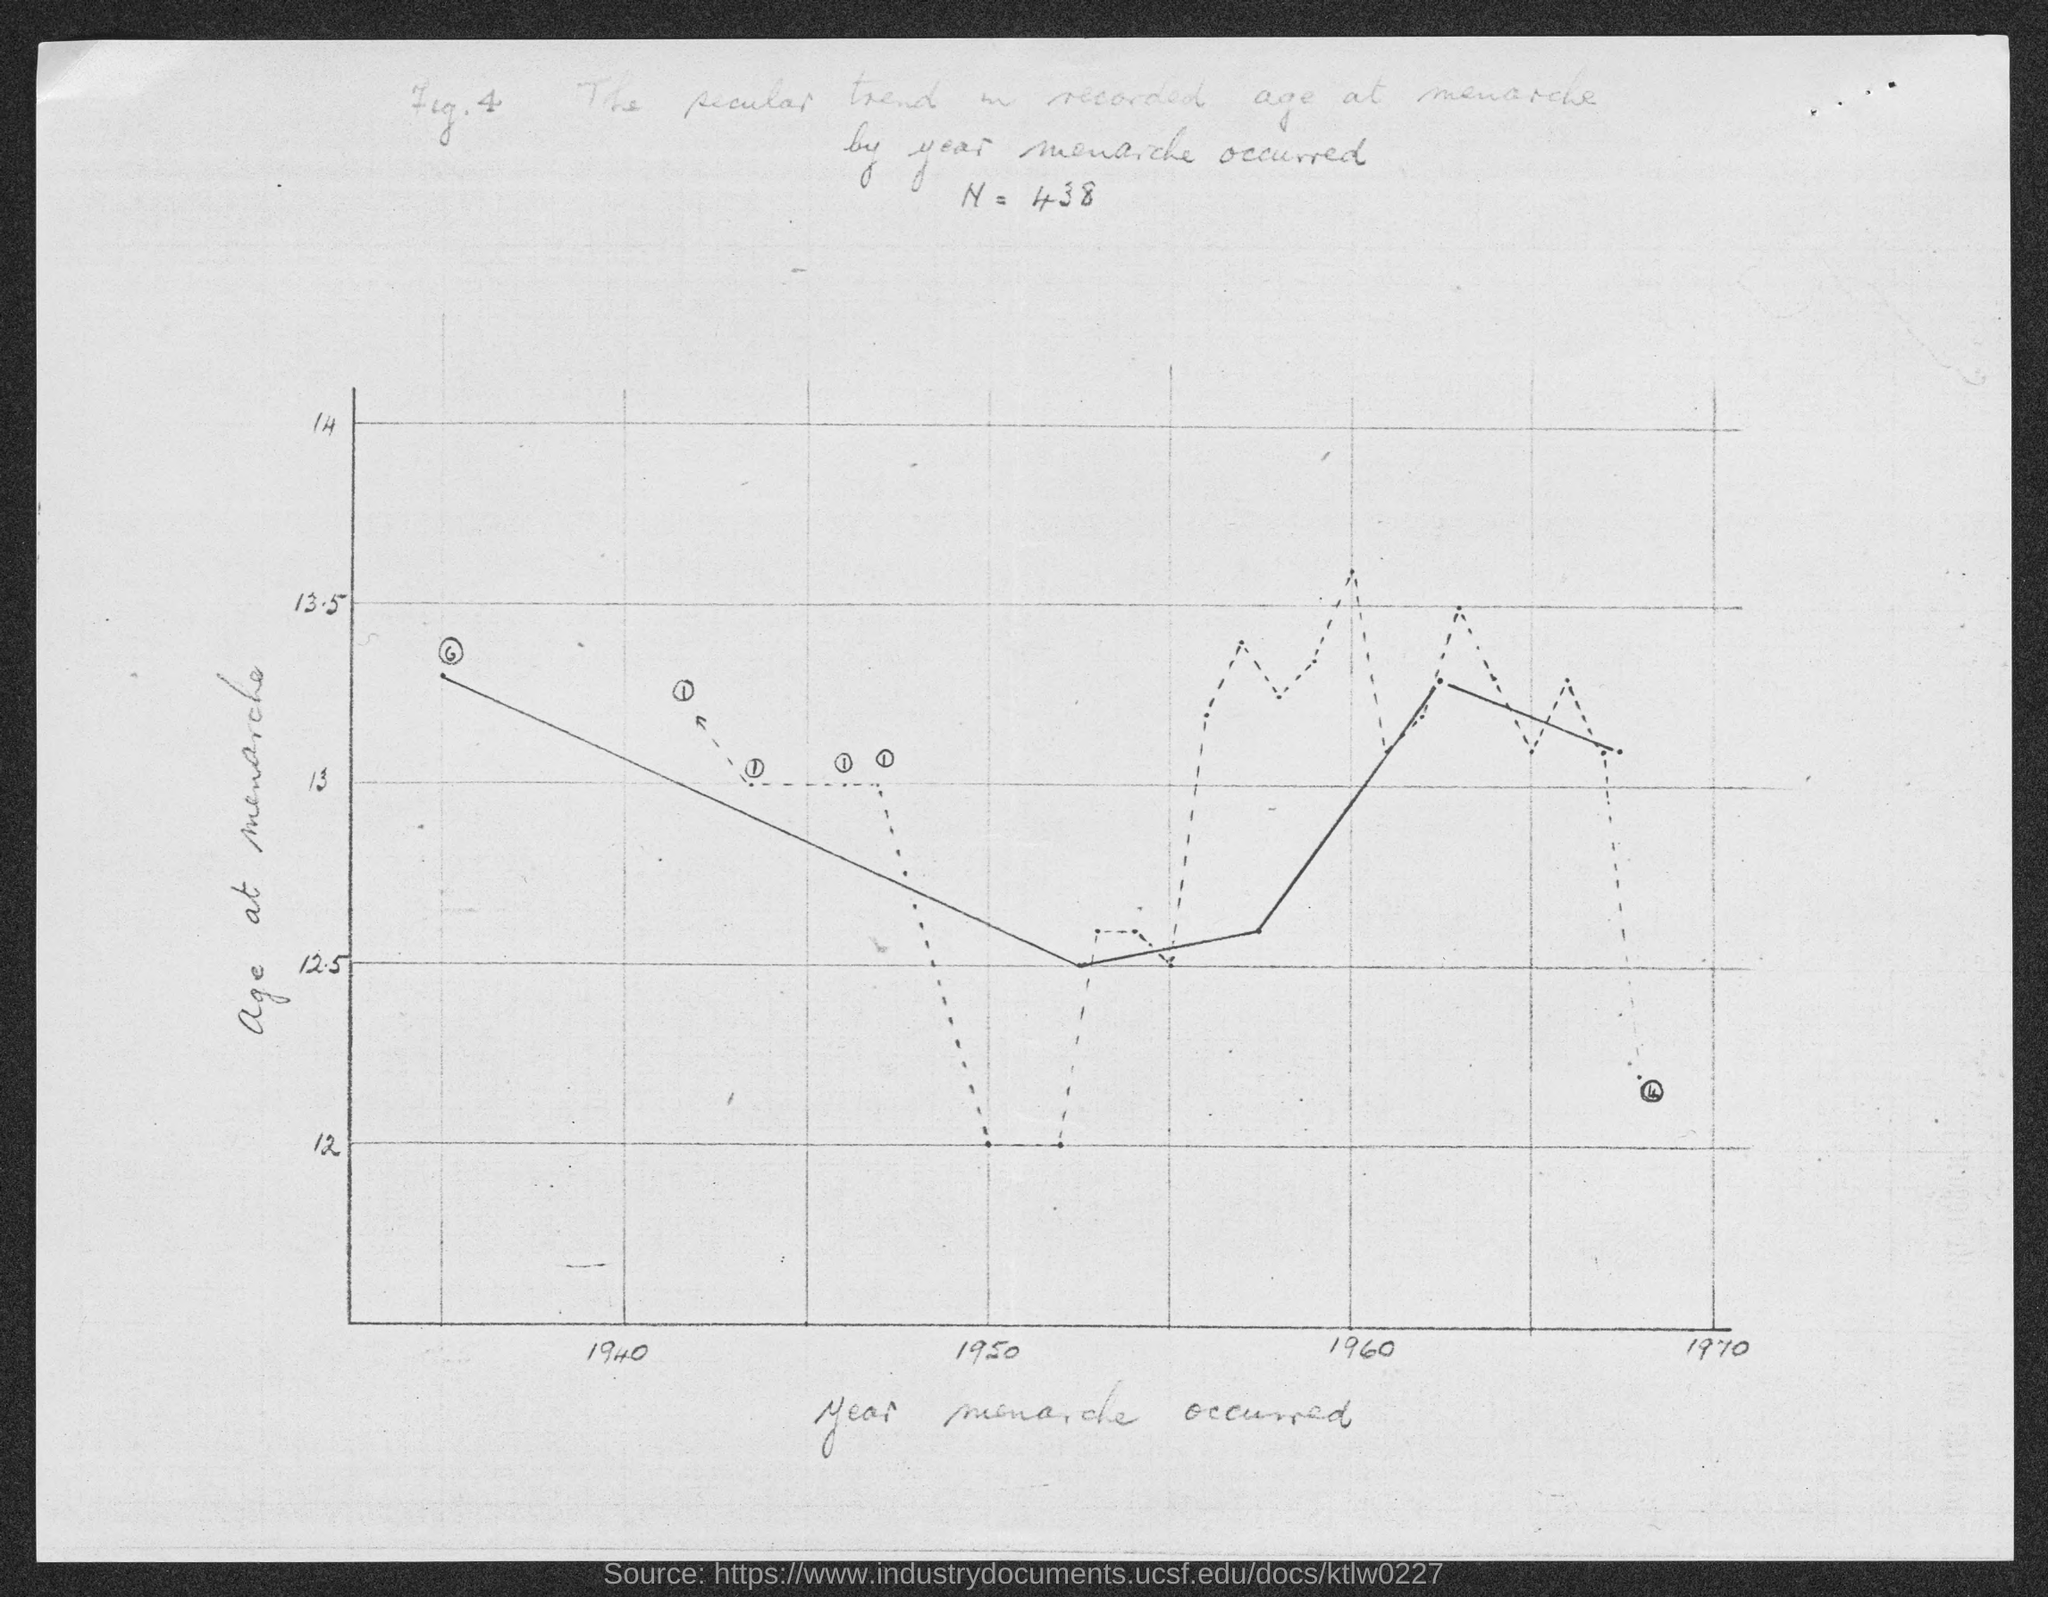What is the value of N?
Offer a terse response. N = 438. What is on the y-axis?
Offer a very short reply. Age at menarche. What is the figure number?
Provide a succinct answer. 4. 